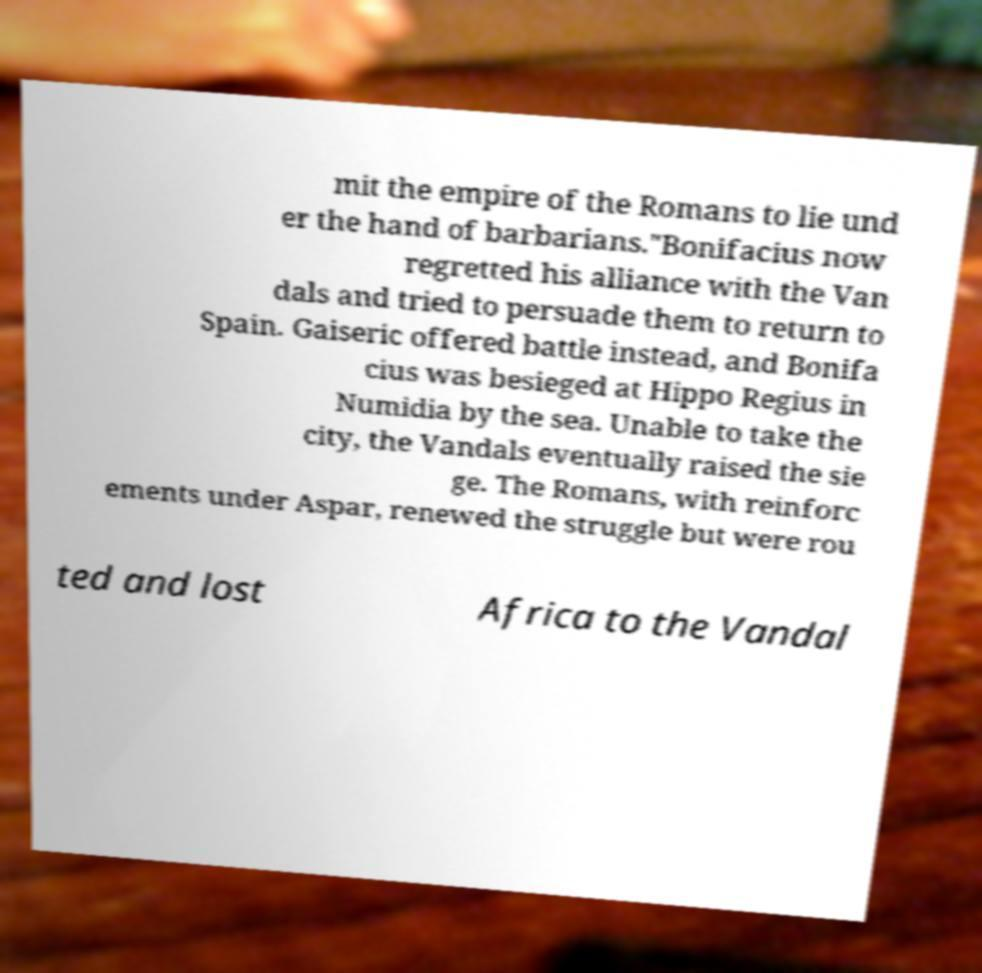Could you assist in decoding the text presented in this image and type it out clearly? mit the empire of the Romans to lie und er the hand of barbarians."Bonifacius now regretted his alliance with the Van dals and tried to persuade them to return to Spain. Gaiseric offered battle instead, and Bonifa cius was besieged at Hippo Regius in Numidia by the sea. Unable to take the city, the Vandals eventually raised the sie ge. The Romans, with reinforc ements under Aspar, renewed the struggle but were rou ted and lost Africa to the Vandal 